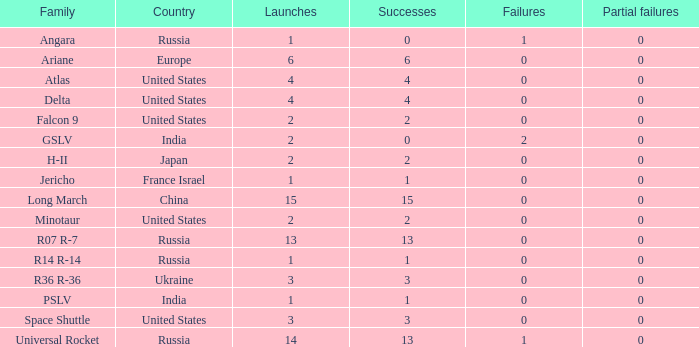What is the partial failure for the Country of russia, and a Failure larger than 0, and a Family of angara, and a Launch larger than 1? None. 